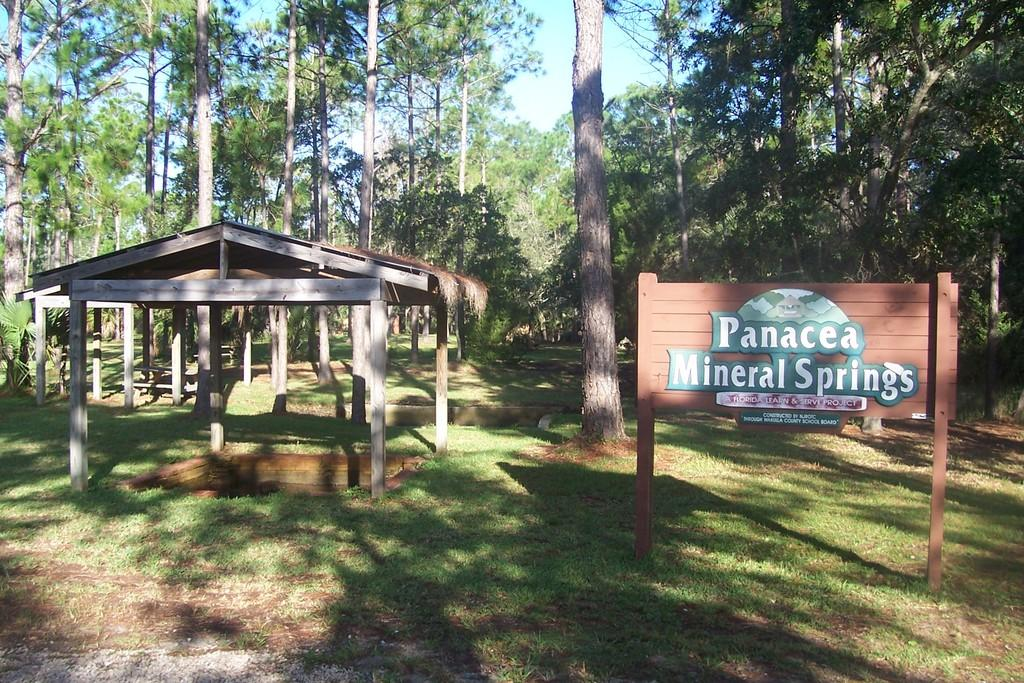What type of vegetation is present in the image? There are many trees in the image. What type of structures can be seen in the image? There are sheds in the image. What object is present in the image that might be used for displaying information or notices? There is a board in the image. What type of vertical supports are visible in the image? There are poles in the image. What type of ground cover is present at the bottom of the image? There is grass at the bottom of the image. How many pizzas are stacked on the shelf in the image? There is no shelf or pizzas present in the image. What type of mist can be seen surrounding the trees in the image? There is no mist present in the image; it is clear and visible. 